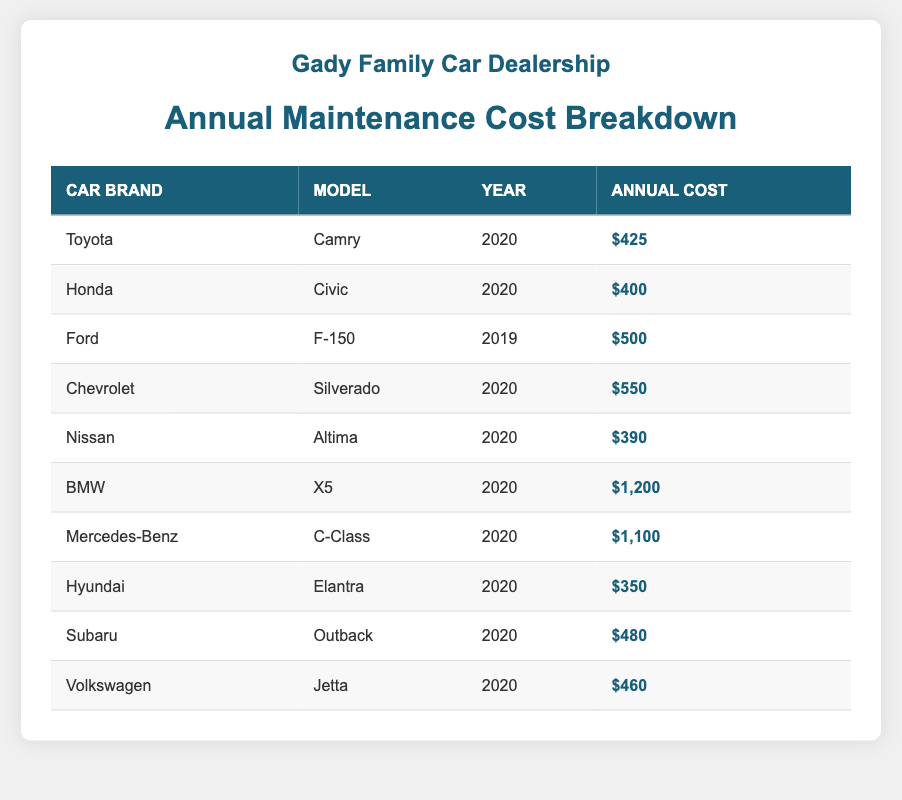What is the annual maintenance cost for a Toyota Camry? The table lists the annual maintenance cost of the Toyota Camry (2020) as $425.
Answer: $425 Which car brand has the highest annual maintenance cost? By comparing all the costs, BMW (X5, 2020) has the highest annual maintenance cost at $1,200.
Answer: BMW What is the annual maintenance cost for a Honda Civic? The table shows that the annual maintenance cost for the Honda Civic (2020) is $400.
Answer: $400 How much does it cost on average to maintain a Chevrolet Silverado and a Ford F-150? The Chevrolet Silverado costs $550 and the Ford F-150 costs $500. The average is (550 + 500) / 2 = $525.
Answer: $525 Is the annual maintenance cost for the Nissan Altima lower than that of the Hyundai Elantra? The Nissan Altima costs $390 while the Hyundai Elantra costs $350. Since $390 is greater than $350, this statement is false.
Answer: No What is the combined annual maintenance cost of the Volkswagen Jetta and Subaru Outback? The Volkswagen Jetta costs $460 and the Subaru Outback costs $480. The combined cost is 460 + 480 = $940.
Answer: $940 Which car model has the lowest annual maintenance cost? The Hyundai Elantra (2020) has the lowest annual maintenance cost at $350, based on the values provided in the table.
Answer: Hyundai Elantra If you were to increase the maintenance costs of all BMW models by 10%, what would be the new cost for the BMW X5? The current cost of the BMW X5 is $1,200. Increasing this by 10% means calculating 1,200 * 0.10 = 120. Thus, the new cost would be 1,200 + 120 = $1,320.
Answer: $1,320 What is the difference in annual maintenance costs between the most expensive and the least expensive car brands? The most expensive is BMW at $1,200 and the least expensive is Hyundai at $350. The difference is 1,200 - 350 = $850.
Answer: $850 Is it true that all 2020 models have a maintenance cost higher than $300? By checking each 2020 model in the table, they all have costs: Toyota (425), Honda (400), Nissan (390), Chevrolet (550), BMW (1200), Mercedes-Benz (1100), Hyundai (350), and Subaru (480), thus, yes, all costs are above $300.
Answer: Yes 